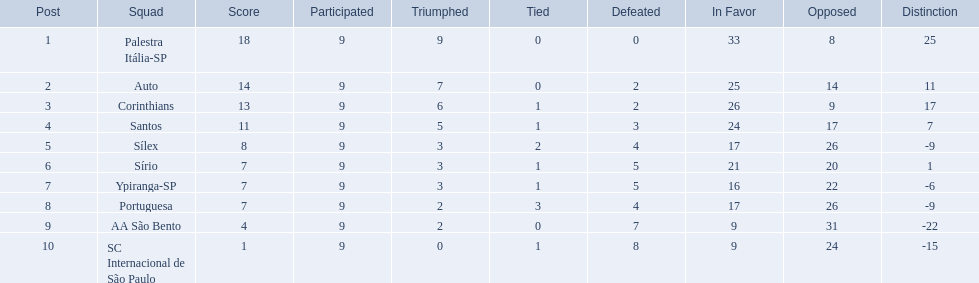What were all the teams that competed in 1926 brazilian football? Palestra Itália-SP, Auto, Corinthians, Santos, Sílex, Sírio, Ypiranga-SP, Portuguesa, AA São Bento, SC Internacional de São Paulo. Which of these had zero games lost? Palestra Itália-SP. How many teams played football in brazil during the year 1926? Palestra Itália-SP, Auto, Corinthians, Santos, Sílex, Sírio, Ypiranga-SP, Portuguesa, AA São Bento, SC Internacional de São Paulo. What was the highest number of games won during the 1926 season? 9. Which team was in the top spot with 9 wins for the 1926 season? Palestra Itália-SP. 